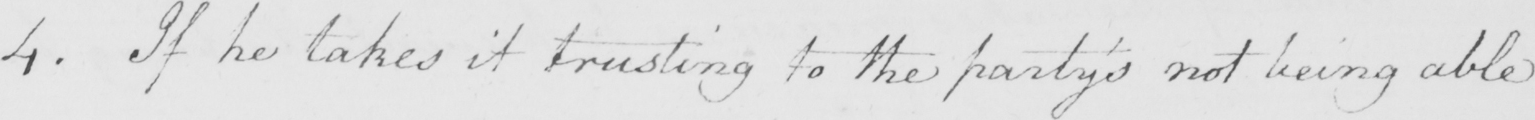What is written in this line of handwriting? 4 . If he takes it trusting to the party ' s not being able 